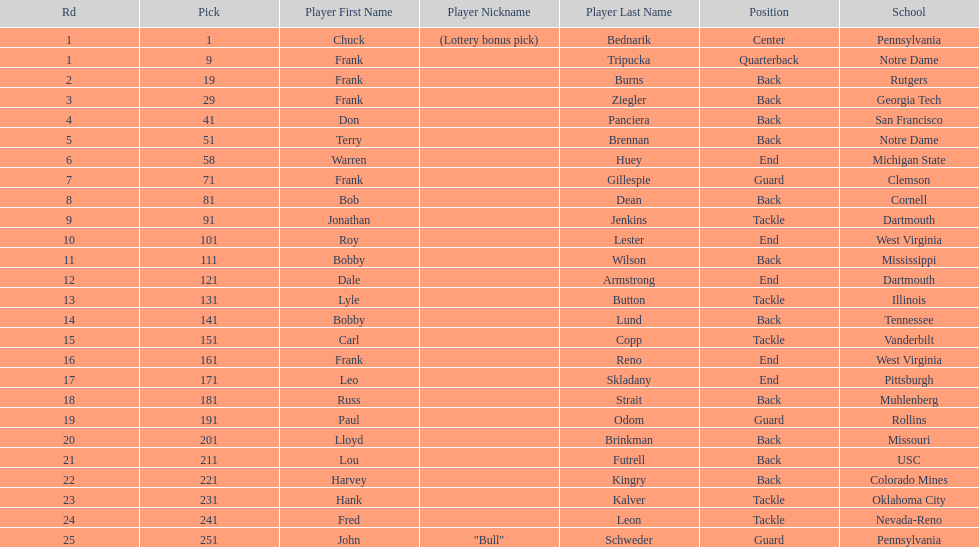Most prevalent school Pennsylvania. 